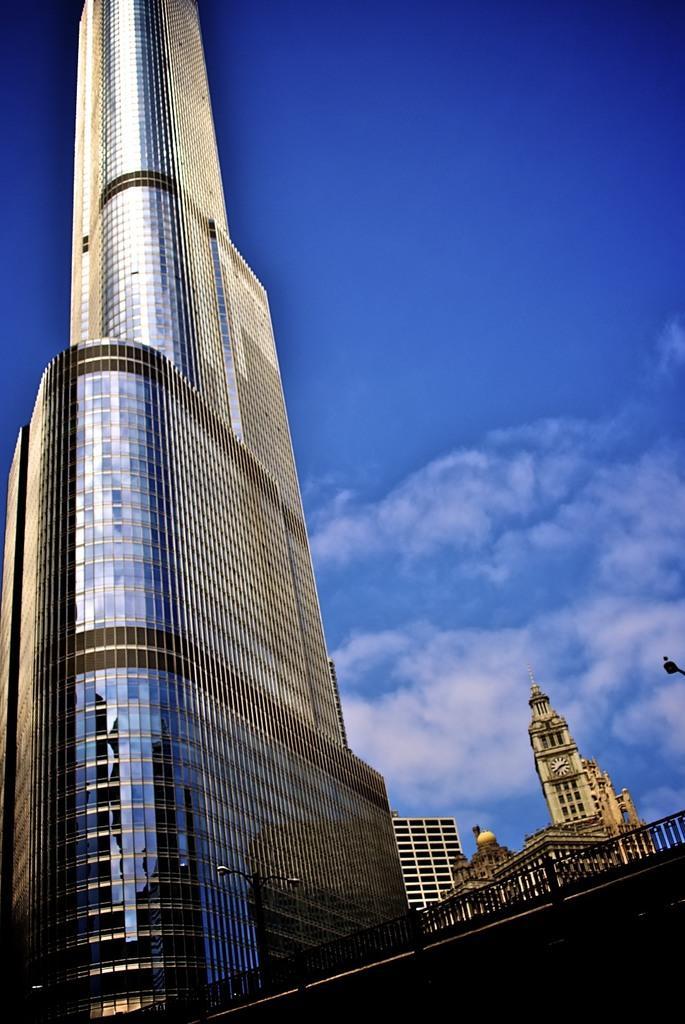In one or two sentences, can you explain what this image depicts? In this picture we can see few buildings, poles, metal rods and clouds. 